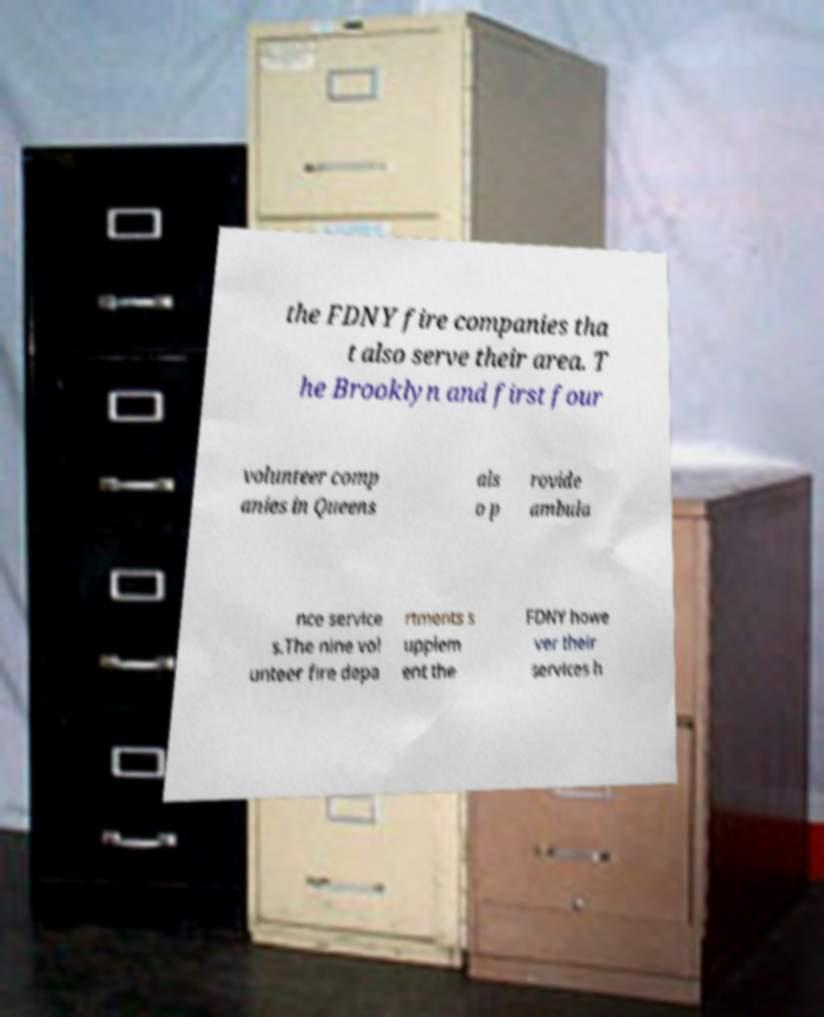What messages or text are displayed in this image? I need them in a readable, typed format. the FDNY fire companies tha t also serve their area. T he Brooklyn and first four volunteer comp anies in Queens als o p rovide ambula nce service s.The nine vol unteer fire depa rtments s upplem ent the FDNY howe ver their services h 